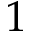Convert formula to latex. <formula><loc_0><loc_0><loc_500><loc_500>1</formula> 